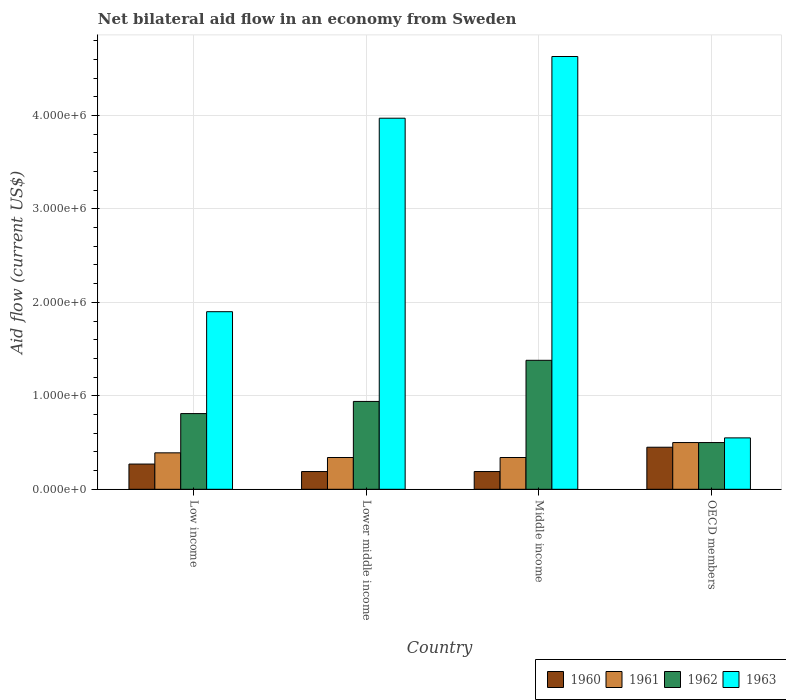How many different coloured bars are there?
Offer a terse response. 4. Are the number of bars per tick equal to the number of legend labels?
Make the answer very short. Yes. How many bars are there on the 3rd tick from the right?
Offer a very short reply. 4. What is the label of the 1st group of bars from the left?
Provide a succinct answer. Low income. What is the net bilateral aid flow in 1962 in Low income?
Your answer should be compact. 8.10e+05. Across all countries, what is the maximum net bilateral aid flow in 1962?
Your answer should be very brief. 1.38e+06. In which country was the net bilateral aid flow in 1960 maximum?
Give a very brief answer. OECD members. In which country was the net bilateral aid flow in 1960 minimum?
Your answer should be compact. Lower middle income. What is the total net bilateral aid flow in 1962 in the graph?
Make the answer very short. 3.63e+06. What is the difference between the net bilateral aid flow in 1962 in Low income and that in Middle income?
Your answer should be compact. -5.70e+05. What is the difference between the net bilateral aid flow in 1960 in Middle income and the net bilateral aid flow in 1962 in OECD members?
Give a very brief answer. -3.10e+05. What is the average net bilateral aid flow in 1960 per country?
Give a very brief answer. 2.75e+05. In how many countries, is the net bilateral aid flow in 1963 greater than 4400000 US$?
Your response must be concise. 1. What is the ratio of the net bilateral aid flow in 1961 in Low income to that in OECD members?
Offer a terse response. 0.78. Is the net bilateral aid flow in 1962 in Low income less than that in Middle income?
Provide a succinct answer. Yes. What is the difference between the highest and the second highest net bilateral aid flow in 1962?
Your response must be concise. 5.70e+05. What is the difference between the highest and the lowest net bilateral aid flow in 1962?
Offer a terse response. 8.80e+05. What does the 3rd bar from the left in Low income represents?
Provide a short and direct response. 1962. What does the 3rd bar from the right in Lower middle income represents?
Keep it short and to the point. 1961. Is it the case that in every country, the sum of the net bilateral aid flow in 1960 and net bilateral aid flow in 1962 is greater than the net bilateral aid flow in 1963?
Ensure brevity in your answer.  No. How many bars are there?
Your answer should be compact. 16. How many countries are there in the graph?
Give a very brief answer. 4. Does the graph contain grids?
Ensure brevity in your answer.  Yes. How many legend labels are there?
Make the answer very short. 4. What is the title of the graph?
Offer a very short reply. Net bilateral aid flow in an economy from Sweden. Does "1989" appear as one of the legend labels in the graph?
Offer a terse response. No. What is the label or title of the X-axis?
Keep it short and to the point. Country. What is the Aid flow (current US$) in 1960 in Low income?
Your answer should be very brief. 2.70e+05. What is the Aid flow (current US$) in 1961 in Low income?
Your response must be concise. 3.90e+05. What is the Aid flow (current US$) of 1962 in Low income?
Give a very brief answer. 8.10e+05. What is the Aid flow (current US$) in 1963 in Low income?
Make the answer very short. 1.90e+06. What is the Aid flow (current US$) in 1962 in Lower middle income?
Your answer should be very brief. 9.40e+05. What is the Aid flow (current US$) in 1963 in Lower middle income?
Provide a succinct answer. 3.97e+06. What is the Aid flow (current US$) in 1960 in Middle income?
Your response must be concise. 1.90e+05. What is the Aid flow (current US$) in 1961 in Middle income?
Provide a short and direct response. 3.40e+05. What is the Aid flow (current US$) in 1962 in Middle income?
Keep it short and to the point. 1.38e+06. What is the Aid flow (current US$) in 1963 in Middle income?
Keep it short and to the point. 4.63e+06. What is the Aid flow (current US$) in 1960 in OECD members?
Give a very brief answer. 4.50e+05. What is the Aid flow (current US$) in 1961 in OECD members?
Your answer should be compact. 5.00e+05. What is the Aid flow (current US$) of 1963 in OECD members?
Provide a succinct answer. 5.50e+05. Across all countries, what is the maximum Aid flow (current US$) of 1962?
Ensure brevity in your answer.  1.38e+06. Across all countries, what is the maximum Aid flow (current US$) of 1963?
Your answer should be very brief. 4.63e+06. Across all countries, what is the minimum Aid flow (current US$) in 1960?
Keep it short and to the point. 1.90e+05. Across all countries, what is the minimum Aid flow (current US$) of 1961?
Provide a short and direct response. 3.40e+05. Across all countries, what is the minimum Aid flow (current US$) of 1963?
Your answer should be very brief. 5.50e+05. What is the total Aid flow (current US$) in 1960 in the graph?
Make the answer very short. 1.10e+06. What is the total Aid flow (current US$) of 1961 in the graph?
Offer a very short reply. 1.57e+06. What is the total Aid flow (current US$) of 1962 in the graph?
Make the answer very short. 3.63e+06. What is the total Aid flow (current US$) of 1963 in the graph?
Ensure brevity in your answer.  1.10e+07. What is the difference between the Aid flow (current US$) of 1960 in Low income and that in Lower middle income?
Make the answer very short. 8.00e+04. What is the difference between the Aid flow (current US$) of 1963 in Low income and that in Lower middle income?
Your answer should be very brief. -2.07e+06. What is the difference between the Aid flow (current US$) of 1960 in Low income and that in Middle income?
Provide a short and direct response. 8.00e+04. What is the difference between the Aid flow (current US$) in 1961 in Low income and that in Middle income?
Your answer should be very brief. 5.00e+04. What is the difference between the Aid flow (current US$) of 1962 in Low income and that in Middle income?
Provide a short and direct response. -5.70e+05. What is the difference between the Aid flow (current US$) in 1963 in Low income and that in Middle income?
Your answer should be very brief. -2.73e+06. What is the difference between the Aid flow (current US$) in 1960 in Low income and that in OECD members?
Your answer should be very brief. -1.80e+05. What is the difference between the Aid flow (current US$) in 1962 in Low income and that in OECD members?
Keep it short and to the point. 3.10e+05. What is the difference between the Aid flow (current US$) in 1963 in Low income and that in OECD members?
Keep it short and to the point. 1.35e+06. What is the difference between the Aid flow (current US$) in 1962 in Lower middle income and that in Middle income?
Offer a very short reply. -4.40e+05. What is the difference between the Aid flow (current US$) of 1963 in Lower middle income and that in Middle income?
Your answer should be compact. -6.60e+05. What is the difference between the Aid flow (current US$) in 1960 in Lower middle income and that in OECD members?
Ensure brevity in your answer.  -2.60e+05. What is the difference between the Aid flow (current US$) of 1961 in Lower middle income and that in OECD members?
Offer a terse response. -1.60e+05. What is the difference between the Aid flow (current US$) in 1963 in Lower middle income and that in OECD members?
Provide a short and direct response. 3.42e+06. What is the difference between the Aid flow (current US$) of 1962 in Middle income and that in OECD members?
Your answer should be compact. 8.80e+05. What is the difference between the Aid flow (current US$) in 1963 in Middle income and that in OECD members?
Offer a terse response. 4.08e+06. What is the difference between the Aid flow (current US$) in 1960 in Low income and the Aid flow (current US$) in 1962 in Lower middle income?
Ensure brevity in your answer.  -6.70e+05. What is the difference between the Aid flow (current US$) in 1960 in Low income and the Aid flow (current US$) in 1963 in Lower middle income?
Provide a succinct answer. -3.70e+06. What is the difference between the Aid flow (current US$) in 1961 in Low income and the Aid flow (current US$) in 1962 in Lower middle income?
Provide a short and direct response. -5.50e+05. What is the difference between the Aid flow (current US$) of 1961 in Low income and the Aid flow (current US$) of 1963 in Lower middle income?
Keep it short and to the point. -3.58e+06. What is the difference between the Aid flow (current US$) of 1962 in Low income and the Aid flow (current US$) of 1963 in Lower middle income?
Keep it short and to the point. -3.16e+06. What is the difference between the Aid flow (current US$) of 1960 in Low income and the Aid flow (current US$) of 1961 in Middle income?
Make the answer very short. -7.00e+04. What is the difference between the Aid flow (current US$) in 1960 in Low income and the Aid flow (current US$) in 1962 in Middle income?
Provide a succinct answer. -1.11e+06. What is the difference between the Aid flow (current US$) of 1960 in Low income and the Aid flow (current US$) of 1963 in Middle income?
Provide a succinct answer. -4.36e+06. What is the difference between the Aid flow (current US$) in 1961 in Low income and the Aid flow (current US$) in 1962 in Middle income?
Give a very brief answer. -9.90e+05. What is the difference between the Aid flow (current US$) in 1961 in Low income and the Aid flow (current US$) in 1963 in Middle income?
Offer a very short reply. -4.24e+06. What is the difference between the Aid flow (current US$) of 1962 in Low income and the Aid flow (current US$) of 1963 in Middle income?
Provide a short and direct response. -3.82e+06. What is the difference between the Aid flow (current US$) of 1960 in Low income and the Aid flow (current US$) of 1961 in OECD members?
Offer a terse response. -2.30e+05. What is the difference between the Aid flow (current US$) in 1960 in Low income and the Aid flow (current US$) in 1963 in OECD members?
Offer a very short reply. -2.80e+05. What is the difference between the Aid flow (current US$) of 1961 in Low income and the Aid flow (current US$) of 1962 in OECD members?
Provide a short and direct response. -1.10e+05. What is the difference between the Aid flow (current US$) in 1960 in Lower middle income and the Aid flow (current US$) in 1962 in Middle income?
Provide a succinct answer. -1.19e+06. What is the difference between the Aid flow (current US$) in 1960 in Lower middle income and the Aid flow (current US$) in 1963 in Middle income?
Your response must be concise. -4.44e+06. What is the difference between the Aid flow (current US$) in 1961 in Lower middle income and the Aid flow (current US$) in 1962 in Middle income?
Make the answer very short. -1.04e+06. What is the difference between the Aid flow (current US$) of 1961 in Lower middle income and the Aid flow (current US$) of 1963 in Middle income?
Your answer should be compact. -4.29e+06. What is the difference between the Aid flow (current US$) in 1962 in Lower middle income and the Aid flow (current US$) in 1963 in Middle income?
Ensure brevity in your answer.  -3.69e+06. What is the difference between the Aid flow (current US$) in 1960 in Lower middle income and the Aid flow (current US$) in 1961 in OECD members?
Offer a very short reply. -3.10e+05. What is the difference between the Aid flow (current US$) of 1960 in Lower middle income and the Aid flow (current US$) of 1962 in OECD members?
Keep it short and to the point. -3.10e+05. What is the difference between the Aid flow (current US$) of 1960 in Lower middle income and the Aid flow (current US$) of 1963 in OECD members?
Keep it short and to the point. -3.60e+05. What is the difference between the Aid flow (current US$) in 1961 in Lower middle income and the Aid flow (current US$) in 1963 in OECD members?
Offer a very short reply. -2.10e+05. What is the difference between the Aid flow (current US$) in 1962 in Lower middle income and the Aid flow (current US$) in 1963 in OECD members?
Provide a short and direct response. 3.90e+05. What is the difference between the Aid flow (current US$) of 1960 in Middle income and the Aid flow (current US$) of 1961 in OECD members?
Keep it short and to the point. -3.10e+05. What is the difference between the Aid flow (current US$) in 1960 in Middle income and the Aid flow (current US$) in 1962 in OECD members?
Your response must be concise. -3.10e+05. What is the difference between the Aid flow (current US$) of 1960 in Middle income and the Aid flow (current US$) of 1963 in OECD members?
Your answer should be very brief. -3.60e+05. What is the difference between the Aid flow (current US$) in 1961 in Middle income and the Aid flow (current US$) in 1962 in OECD members?
Offer a terse response. -1.60e+05. What is the difference between the Aid flow (current US$) in 1962 in Middle income and the Aid flow (current US$) in 1963 in OECD members?
Your answer should be compact. 8.30e+05. What is the average Aid flow (current US$) in 1960 per country?
Offer a very short reply. 2.75e+05. What is the average Aid flow (current US$) of 1961 per country?
Keep it short and to the point. 3.92e+05. What is the average Aid flow (current US$) of 1962 per country?
Make the answer very short. 9.08e+05. What is the average Aid flow (current US$) in 1963 per country?
Keep it short and to the point. 2.76e+06. What is the difference between the Aid flow (current US$) of 1960 and Aid flow (current US$) of 1961 in Low income?
Provide a succinct answer. -1.20e+05. What is the difference between the Aid flow (current US$) in 1960 and Aid flow (current US$) in 1962 in Low income?
Offer a very short reply. -5.40e+05. What is the difference between the Aid flow (current US$) of 1960 and Aid flow (current US$) of 1963 in Low income?
Provide a short and direct response. -1.63e+06. What is the difference between the Aid flow (current US$) of 1961 and Aid flow (current US$) of 1962 in Low income?
Your answer should be compact. -4.20e+05. What is the difference between the Aid flow (current US$) in 1961 and Aid flow (current US$) in 1963 in Low income?
Offer a very short reply. -1.51e+06. What is the difference between the Aid flow (current US$) of 1962 and Aid flow (current US$) of 1963 in Low income?
Give a very brief answer. -1.09e+06. What is the difference between the Aid flow (current US$) in 1960 and Aid flow (current US$) in 1961 in Lower middle income?
Offer a very short reply. -1.50e+05. What is the difference between the Aid flow (current US$) of 1960 and Aid flow (current US$) of 1962 in Lower middle income?
Your response must be concise. -7.50e+05. What is the difference between the Aid flow (current US$) of 1960 and Aid flow (current US$) of 1963 in Lower middle income?
Give a very brief answer. -3.78e+06. What is the difference between the Aid flow (current US$) in 1961 and Aid flow (current US$) in 1962 in Lower middle income?
Ensure brevity in your answer.  -6.00e+05. What is the difference between the Aid flow (current US$) of 1961 and Aid flow (current US$) of 1963 in Lower middle income?
Keep it short and to the point. -3.63e+06. What is the difference between the Aid flow (current US$) in 1962 and Aid flow (current US$) in 1963 in Lower middle income?
Keep it short and to the point. -3.03e+06. What is the difference between the Aid flow (current US$) in 1960 and Aid flow (current US$) in 1961 in Middle income?
Give a very brief answer. -1.50e+05. What is the difference between the Aid flow (current US$) in 1960 and Aid flow (current US$) in 1962 in Middle income?
Your response must be concise. -1.19e+06. What is the difference between the Aid flow (current US$) in 1960 and Aid flow (current US$) in 1963 in Middle income?
Your answer should be very brief. -4.44e+06. What is the difference between the Aid flow (current US$) of 1961 and Aid flow (current US$) of 1962 in Middle income?
Offer a very short reply. -1.04e+06. What is the difference between the Aid flow (current US$) in 1961 and Aid flow (current US$) in 1963 in Middle income?
Your answer should be compact. -4.29e+06. What is the difference between the Aid flow (current US$) of 1962 and Aid flow (current US$) of 1963 in Middle income?
Your response must be concise. -3.25e+06. What is the difference between the Aid flow (current US$) in 1960 and Aid flow (current US$) in 1963 in OECD members?
Keep it short and to the point. -1.00e+05. What is the difference between the Aid flow (current US$) of 1961 and Aid flow (current US$) of 1962 in OECD members?
Your answer should be compact. 0. What is the ratio of the Aid flow (current US$) of 1960 in Low income to that in Lower middle income?
Offer a terse response. 1.42. What is the ratio of the Aid flow (current US$) in 1961 in Low income to that in Lower middle income?
Your answer should be compact. 1.15. What is the ratio of the Aid flow (current US$) in 1962 in Low income to that in Lower middle income?
Your answer should be very brief. 0.86. What is the ratio of the Aid flow (current US$) in 1963 in Low income to that in Lower middle income?
Your answer should be compact. 0.48. What is the ratio of the Aid flow (current US$) in 1960 in Low income to that in Middle income?
Make the answer very short. 1.42. What is the ratio of the Aid flow (current US$) in 1961 in Low income to that in Middle income?
Your answer should be very brief. 1.15. What is the ratio of the Aid flow (current US$) in 1962 in Low income to that in Middle income?
Ensure brevity in your answer.  0.59. What is the ratio of the Aid flow (current US$) in 1963 in Low income to that in Middle income?
Give a very brief answer. 0.41. What is the ratio of the Aid flow (current US$) in 1960 in Low income to that in OECD members?
Provide a short and direct response. 0.6. What is the ratio of the Aid flow (current US$) in 1961 in Low income to that in OECD members?
Make the answer very short. 0.78. What is the ratio of the Aid flow (current US$) of 1962 in Low income to that in OECD members?
Give a very brief answer. 1.62. What is the ratio of the Aid flow (current US$) in 1963 in Low income to that in OECD members?
Give a very brief answer. 3.45. What is the ratio of the Aid flow (current US$) of 1960 in Lower middle income to that in Middle income?
Your answer should be very brief. 1. What is the ratio of the Aid flow (current US$) in 1961 in Lower middle income to that in Middle income?
Provide a short and direct response. 1. What is the ratio of the Aid flow (current US$) of 1962 in Lower middle income to that in Middle income?
Offer a terse response. 0.68. What is the ratio of the Aid flow (current US$) of 1963 in Lower middle income to that in Middle income?
Offer a terse response. 0.86. What is the ratio of the Aid flow (current US$) of 1960 in Lower middle income to that in OECD members?
Give a very brief answer. 0.42. What is the ratio of the Aid flow (current US$) in 1961 in Lower middle income to that in OECD members?
Provide a succinct answer. 0.68. What is the ratio of the Aid flow (current US$) in 1962 in Lower middle income to that in OECD members?
Your answer should be compact. 1.88. What is the ratio of the Aid flow (current US$) in 1963 in Lower middle income to that in OECD members?
Make the answer very short. 7.22. What is the ratio of the Aid flow (current US$) in 1960 in Middle income to that in OECD members?
Offer a terse response. 0.42. What is the ratio of the Aid flow (current US$) in 1961 in Middle income to that in OECD members?
Provide a succinct answer. 0.68. What is the ratio of the Aid flow (current US$) of 1962 in Middle income to that in OECD members?
Keep it short and to the point. 2.76. What is the ratio of the Aid flow (current US$) in 1963 in Middle income to that in OECD members?
Keep it short and to the point. 8.42. What is the difference between the highest and the second highest Aid flow (current US$) in 1963?
Your response must be concise. 6.60e+05. What is the difference between the highest and the lowest Aid flow (current US$) in 1960?
Offer a terse response. 2.60e+05. What is the difference between the highest and the lowest Aid flow (current US$) in 1962?
Offer a terse response. 8.80e+05. What is the difference between the highest and the lowest Aid flow (current US$) in 1963?
Offer a very short reply. 4.08e+06. 